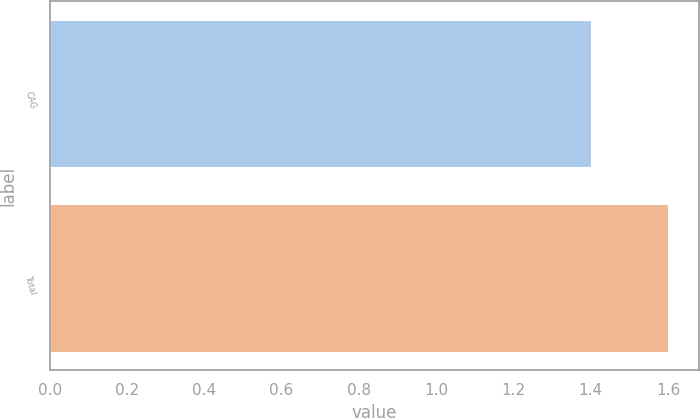<chart> <loc_0><loc_0><loc_500><loc_500><bar_chart><fcel>CAG<fcel>Total<nl><fcel>1.4<fcel>1.6<nl></chart> 